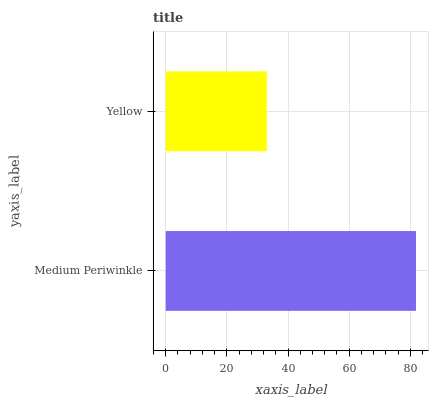Is Yellow the minimum?
Answer yes or no. Yes. Is Medium Periwinkle the maximum?
Answer yes or no. Yes. Is Yellow the maximum?
Answer yes or no. No. Is Medium Periwinkle greater than Yellow?
Answer yes or no. Yes. Is Yellow less than Medium Periwinkle?
Answer yes or no. Yes. Is Yellow greater than Medium Periwinkle?
Answer yes or no. No. Is Medium Periwinkle less than Yellow?
Answer yes or no. No. Is Medium Periwinkle the high median?
Answer yes or no. Yes. Is Yellow the low median?
Answer yes or no. Yes. Is Yellow the high median?
Answer yes or no. No. Is Medium Periwinkle the low median?
Answer yes or no. No. 